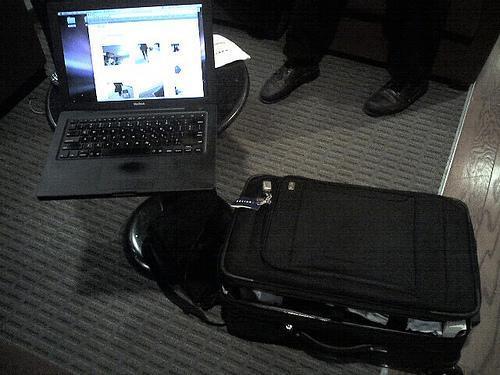How many laptop on the table?
Give a very brief answer. 1. 